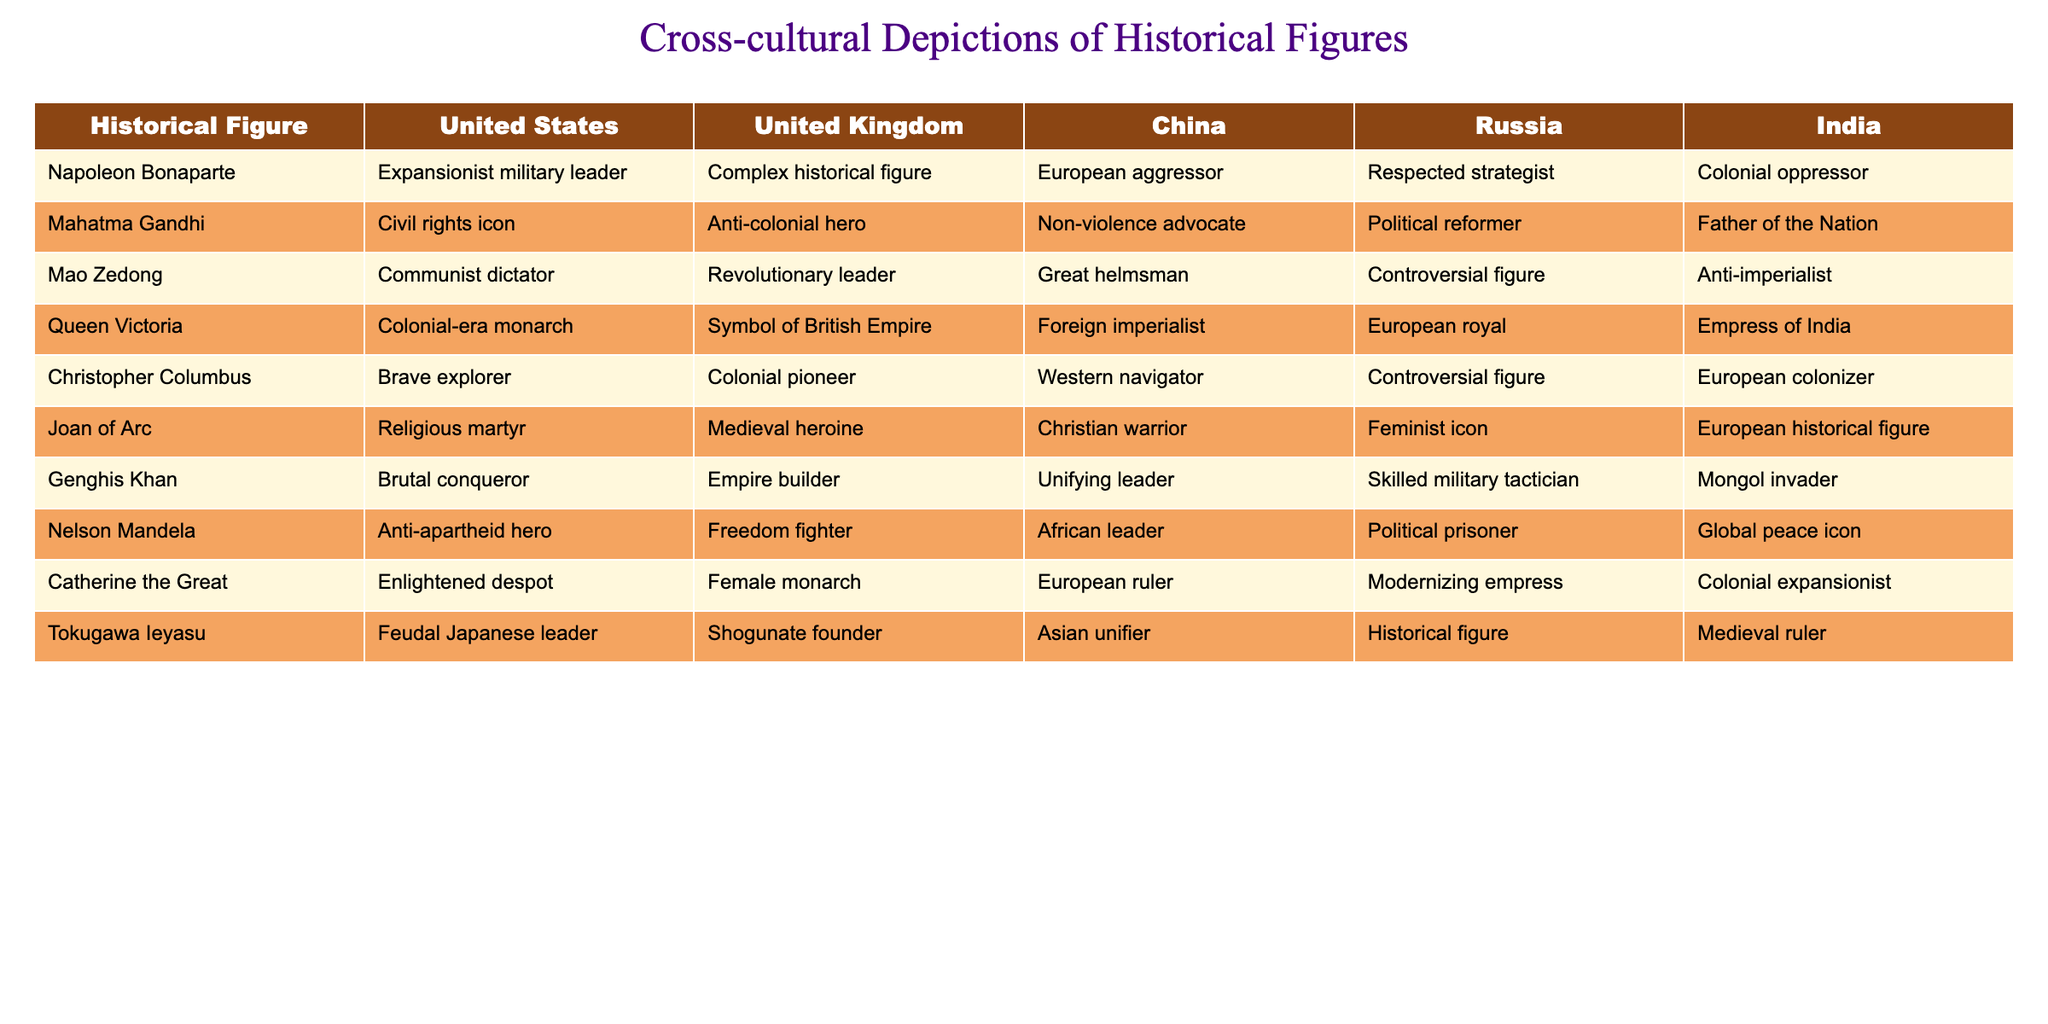What are the perceptions of Napoleon Bonaparte in the United States and Russia? In the table, the perception of Napoleon Bonaparte in the United States is described as an "Expansionist military leader," while in Russia, he is seen as a "Respected strategist."
Answer: Expansionist military leader; Respected strategist Which historical figure is viewed as a "Colonial oppressor" in India? Referring to the table, the historical figure described as a "Colonial oppressor" in India is Napoleon Bonaparte.
Answer: Napoleon Bonaparte How many countries describe Mahatma Gandhi as a "Civil rights icon"? The table shows that Mahatma Gandhi is described as a "Civil rights icon" only in the United States, thus there is one country describing him this way.
Answer: 1 Is Joan of Arc seen as a "Feminist icon" in the United Kingdom? According to the table, Joan of Arc is described as a "Medieval heroine" in the United Kingdom; therefore, the statement is false.
Answer: No Which historical figure is portrayed most negatively across different countries? By examining the descriptions, Christopher Columbus is portrayed negatively with terms such as "Controversial figure" in Russia and "European colonizer" in India, making him perceived negatively in multiple contexts.
Answer: Christopher Columbus In how many countries is Genghis Khan referred to as a "Skilled military tactician"? From the table, Genghis Khan is referred to as a "Skilled military tactician" only in Russia. Thus, the number of countries is one.
Answer: 1 What common trait is ascribed to both Nelson Mandela and Mahatma Gandhi across different countries? Both Nelson Mandela and Mahatma Gandhi are consistently recognized as advocates for peace; Mandela as an "Anti-apartheid hero" and Gandhi as a "Non-violence advocate."
Answer: Advocacy for peace Which historical figure appears with the same title in both India and the United Kingdom? In the table, the historical figure Queen Victoria is described as "Empress of India" in India and "Colonial-era monarch" in the United Kingdom, which reflects her role in both countries without a single matching title.
Answer: None What is the contrast in how Mao Zedong is perceived in the United States versus China? Mao Zedong is viewed negatively in the United States as a "Communist dictator," while in China, he is described more positively as the "Great helmsman." This signifies a significant contrast in perception between the two cultures.
Answer: Contrasting views How do the descriptions of Catherine the Great in the United Kingdom and Russia differ? In the United Kingdom, Catherine the Great is called an "Enlightened despot," while in Russia, she is referred to as a "Modernizing empress," indicating a nuance in her portrayal depending on the cultural perspective.
Answer: Differing portrayals 